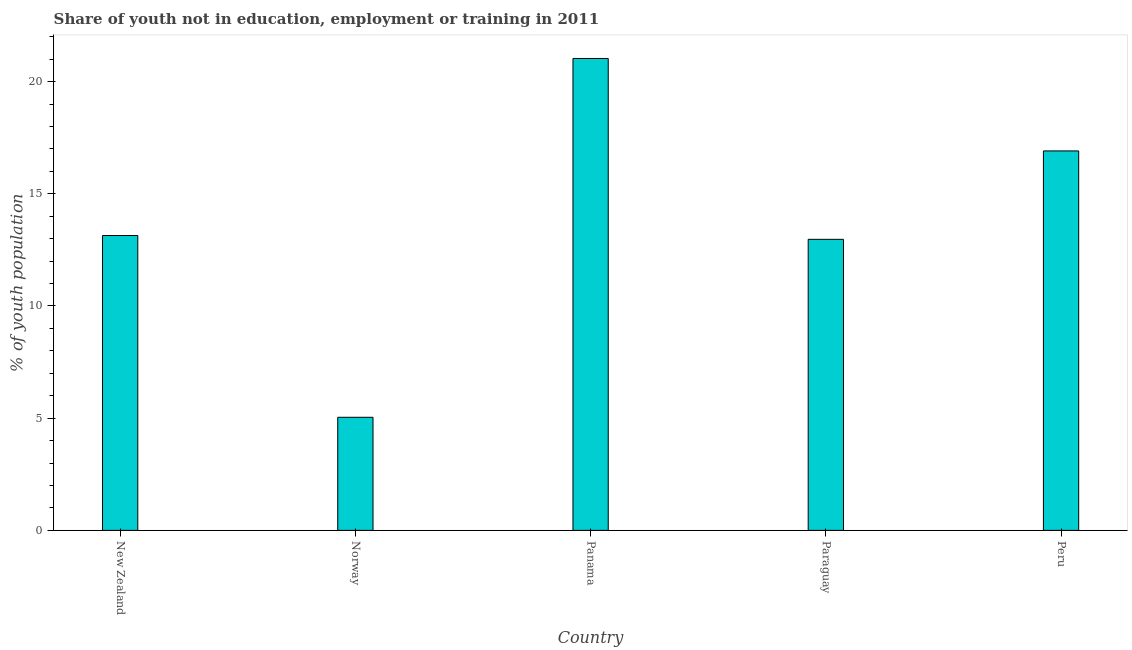Does the graph contain any zero values?
Provide a succinct answer. No. Does the graph contain grids?
Your response must be concise. No. What is the title of the graph?
Keep it short and to the point. Share of youth not in education, employment or training in 2011. What is the label or title of the Y-axis?
Your answer should be very brief. % of youth population. What is the unemployed youth population in Panama?
Keep it short and to the point. 21.03. Across all countries, what is the maximum unemployed youth population?
Make the answer very short. 21.03. Across all countries, what is the minimum unemployed youth population?
Offer a terse response. 5.04. In which country was the unemployed youth population maximum?
Keep it short and to the point. Panama. What is the sum of the unemployed youth population?
Your answer should be compact. 69.09. What is the difference between the unemployed youth population in Norway and Peru?
Provide a short and direct response. -11.87. What is the average unemployed youth population per country?
Offer a terse response. 13.82. What is the median unemployed youth population?
Offer a very short reply. 13.14. In how many countries, is the unemployed youth population greater than 6 %?
Ensure brevity in your answer.  4. Is the unemployed youth population in Norway less than that in Panama?
Your answer should be compact. Yes. Is the difference between the unemployed youth population in Paraguay and Peru greater than the difference between any two countries?
Provide a succinct answer. No. What is the difference between the highest and the second highest unemployed youth population?
Ensure brevity in your answer.  4.12. What is the difference between the highest and the lowest unemployed youth population?
Your response must be concise. 15.99. How many bars are there?
Make the answer very short. 5. What is the % of youth population in New Zealand?
Offer a very short reply. 13.14. What is the % of youth population of Norway?
Offer a very short reply. 5.04. What is the % of youth population of Panama?
Offer a very short reply. 21.03. What is the % of youth population of Paraguay?
Your answer should be very brief. 12.97. What is the % of youth population of Peru?
Offer a very short reply. 16.91. What is the difference between the % of youth population in New Zealand and Panama?
Your answer should be very brief. -7.89. What is the difference between the % of youth population in New Zealand and Paraguay?
Provide a succinct answer. 0.17. What is the difference between the % of youth population in New Zealand and Peru?
Keep it short and to the point. -3.77. What is the difference between the % of youth population in Norway and Panama?
Your response must be concise. -15.99. What is the difference between the % of youth population in Norway and Paraguay?
Your answer should be very brief. -7.93. What is the difference between the % of youth population in Norway and Peru?
Keep it short and to the point. -11.87. What is the difference between the % of youth population in Panama and Paraguay?
Provide a succinct answer. 8.06. What is the difference between the % of youth population in Panama and Peru?
Your response must be concise. 4.12. What is the difference between the % of youth population in Paraguay and Peru?
Provide a succinct answer. -3.94. What is the ratio of the % of youth population in New Zealand to that in Norway?
Your response must be concise. 2.61. What is the ratio of the % of youth population in New Zealand to that in Panama?
Your answer should be very brief. 0.62. What is the ratio of the % of youth population in New Zealand to that in Peru?
Ensure brevity in your answer.  0.78. What is the ratio of the % of youth population in Norway to that in Panama?
Ensure brevity in your answer.  0.24. What is the ratio of the % of youth population in Norway to that in Paraguay?
Keep it short and to the point. 0.39. What is the ratio of the % of youth population in Norway to that in Peru?
Your answer should be very brief. 0.3. What is the ratio of the % of youth population in Panama to that in Paraguay?
Provide a succinct answer. 1.62. What is the ratio of the % of youth population in Panama to that in Peru?
Make the answer very short. 1.24. What is the ratio of the % of youth population in Paraguay to that in Peru?
Provide a succinct answer. 0.77. 